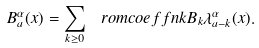<formula> <loc_0><loc_0><loc_500><loc_500>B _ { a } ^ { \alpha } ( x ) = \sum _ { k \geq 0 } \ r o m c o e f f { n } { k } B _ { k } \lambda _ { a - k } ^ { \alpha } ( x ) .</formula> 